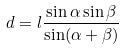Convert formula to latex. <formula><loc_0><loc_0><loc_500><loc_500>d = l \frac { \sin \alpha \sin \beta } { \sin ( \alpha + \beta ) }</formula> 